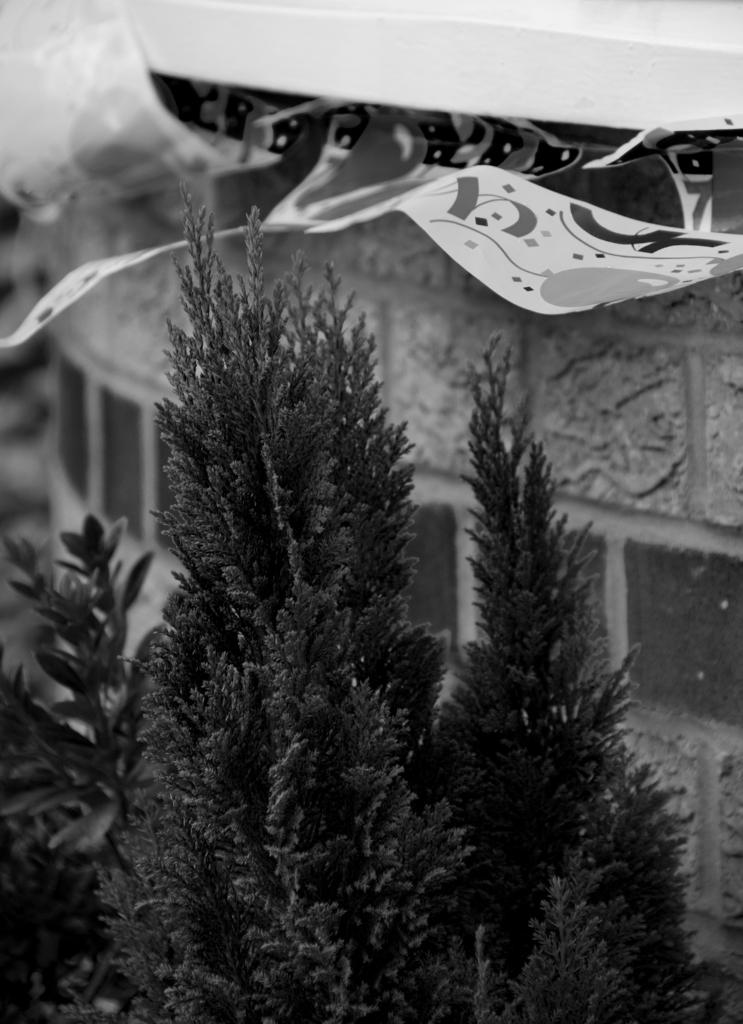What type of living organisms can be seen in the image? Plants can be seen in the image. What color scheme is used in the image? The image is in black and white. What type of zephyr can be seen blowing through the plants in the image? There is no zephyr present in the image, as a zephyr refers to a gentle breeze, and the image is in black and white, which does not convey the presence of wind. 